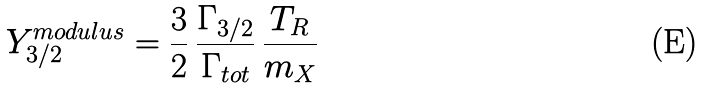<formula> <loc_0><loc_0><loc_500><loc_500>Y _ { 3 / 2 } ^ { m o d u l u s } = \frac { 3 } { 2 } \, \frac { \Gamma _ { 3 / 2 } } { \Gamma _ { t o t } } \, \frac { T _ { R } } { m _ { X } }</formula> 